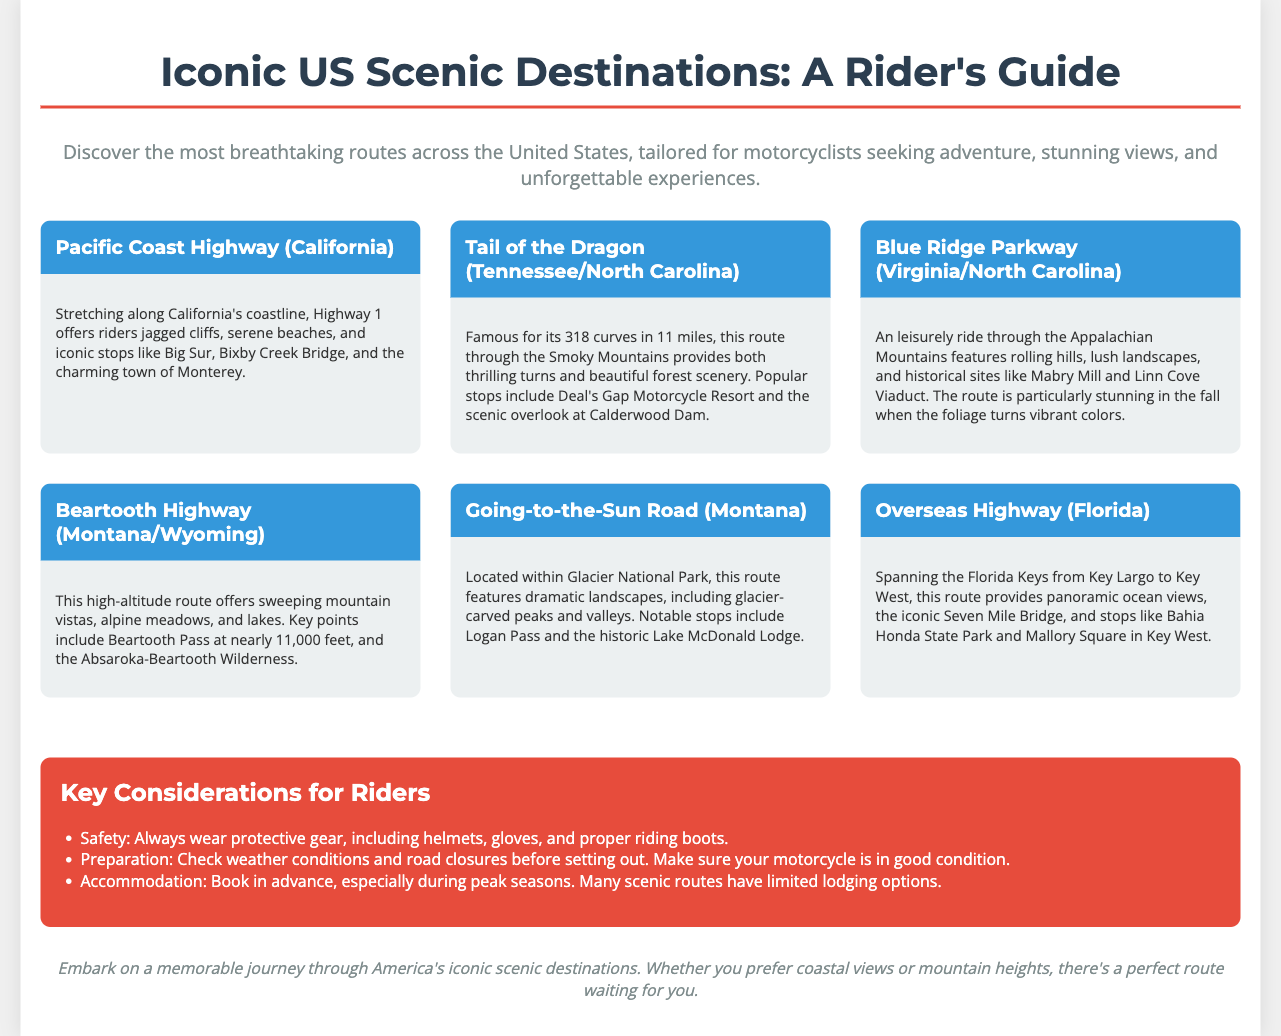What is the title of the guide? The title of the guide is presented at the top of the document and is "Iconic US Scenic Destinations: A Rider's Guide."
Answer: Iconic US Scenic Destinations: A Rider's Guide How many curves are in the Tail of the Dragon? The document states that there are 318 curves in the Tail of the Dragon route.
Answer: 318 What is the highest point on the Beartooth Highway? The Beartooth Pass is noted in the document as nearly 11,000 feet, which is the highest point on the highway.
Answer: nearly 11,000 feet Which destination includes the iconic Seven Mile Bridge? The Overseas Highway is identified in the text as having the iconic Seven Mile Bridge.
Answer: Overseas Highway What is a key consideration for riders according to the document? The document lists safety, preparation, and accommodation as key considerations for riders, mentioned under the "Key Considerations for Riders" section.
Answer: Safety Which states does the Blue Ridge Parkway run through? The document lists the Blue Ridge Parkway as running through Virginia and North Carolina.
Answer: Virginia/North Carolina What is the focus of the infographic? The focus of the infographic is to highlight scenic destinations across the United States specifically for motorcyclists.
Answer: Scenic destinations for motorcyclists What type of document is this? The document is structured as an infographic designed to provide quick and visually appealing information.
Answer: Infographic 